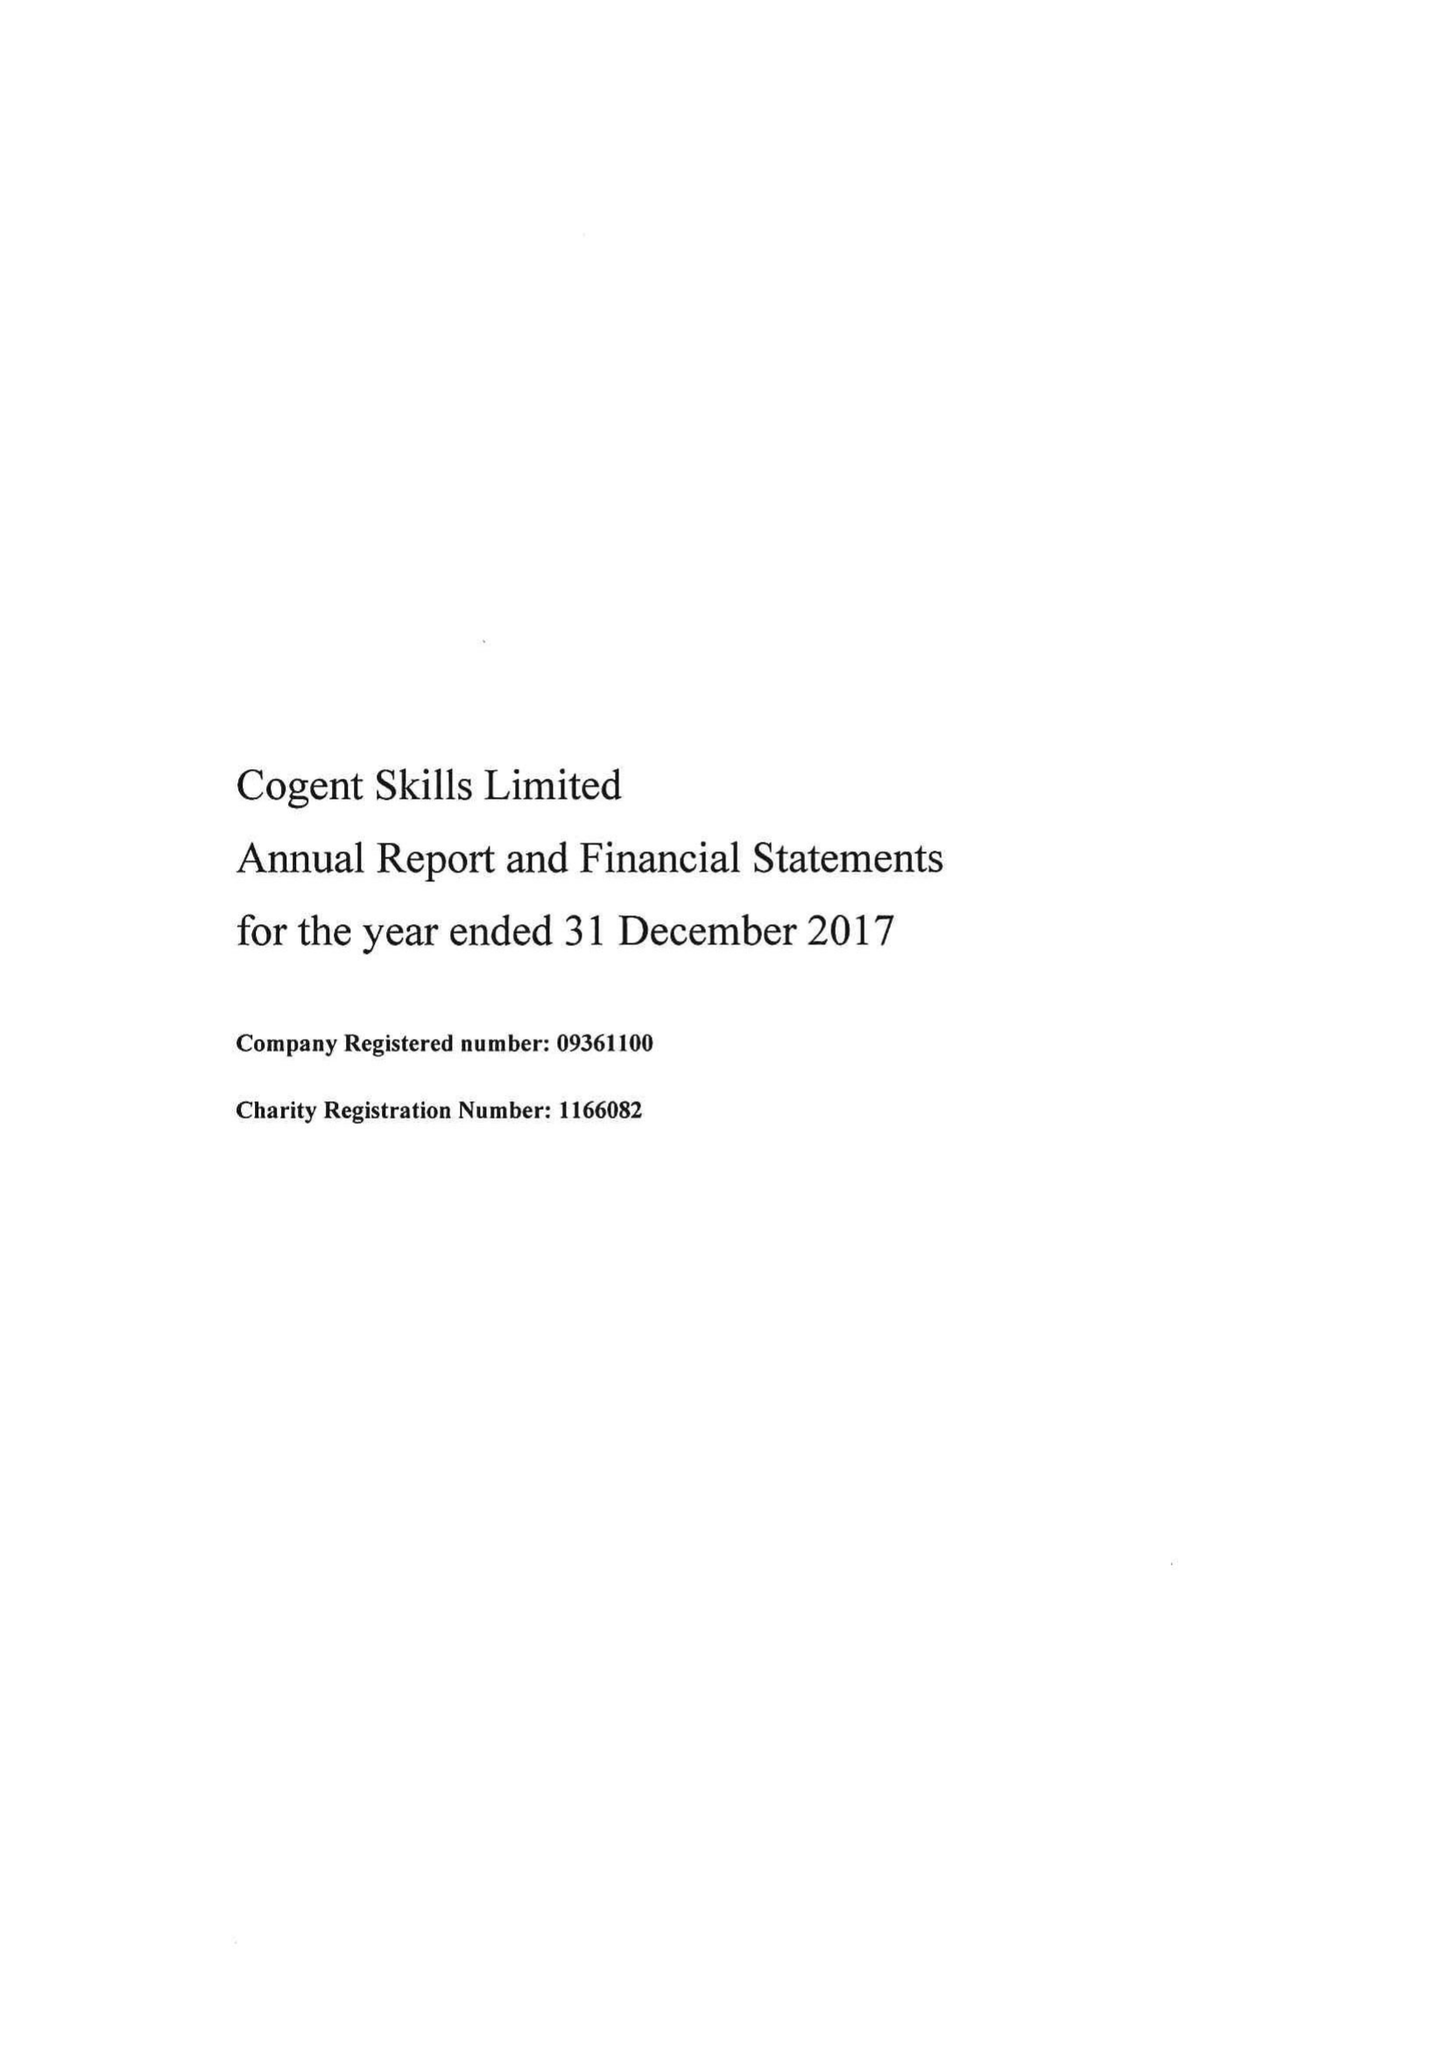What is the value for the income_annually_in_british_pounds?
Answer the question using a single word or phrase. 11699000.00 